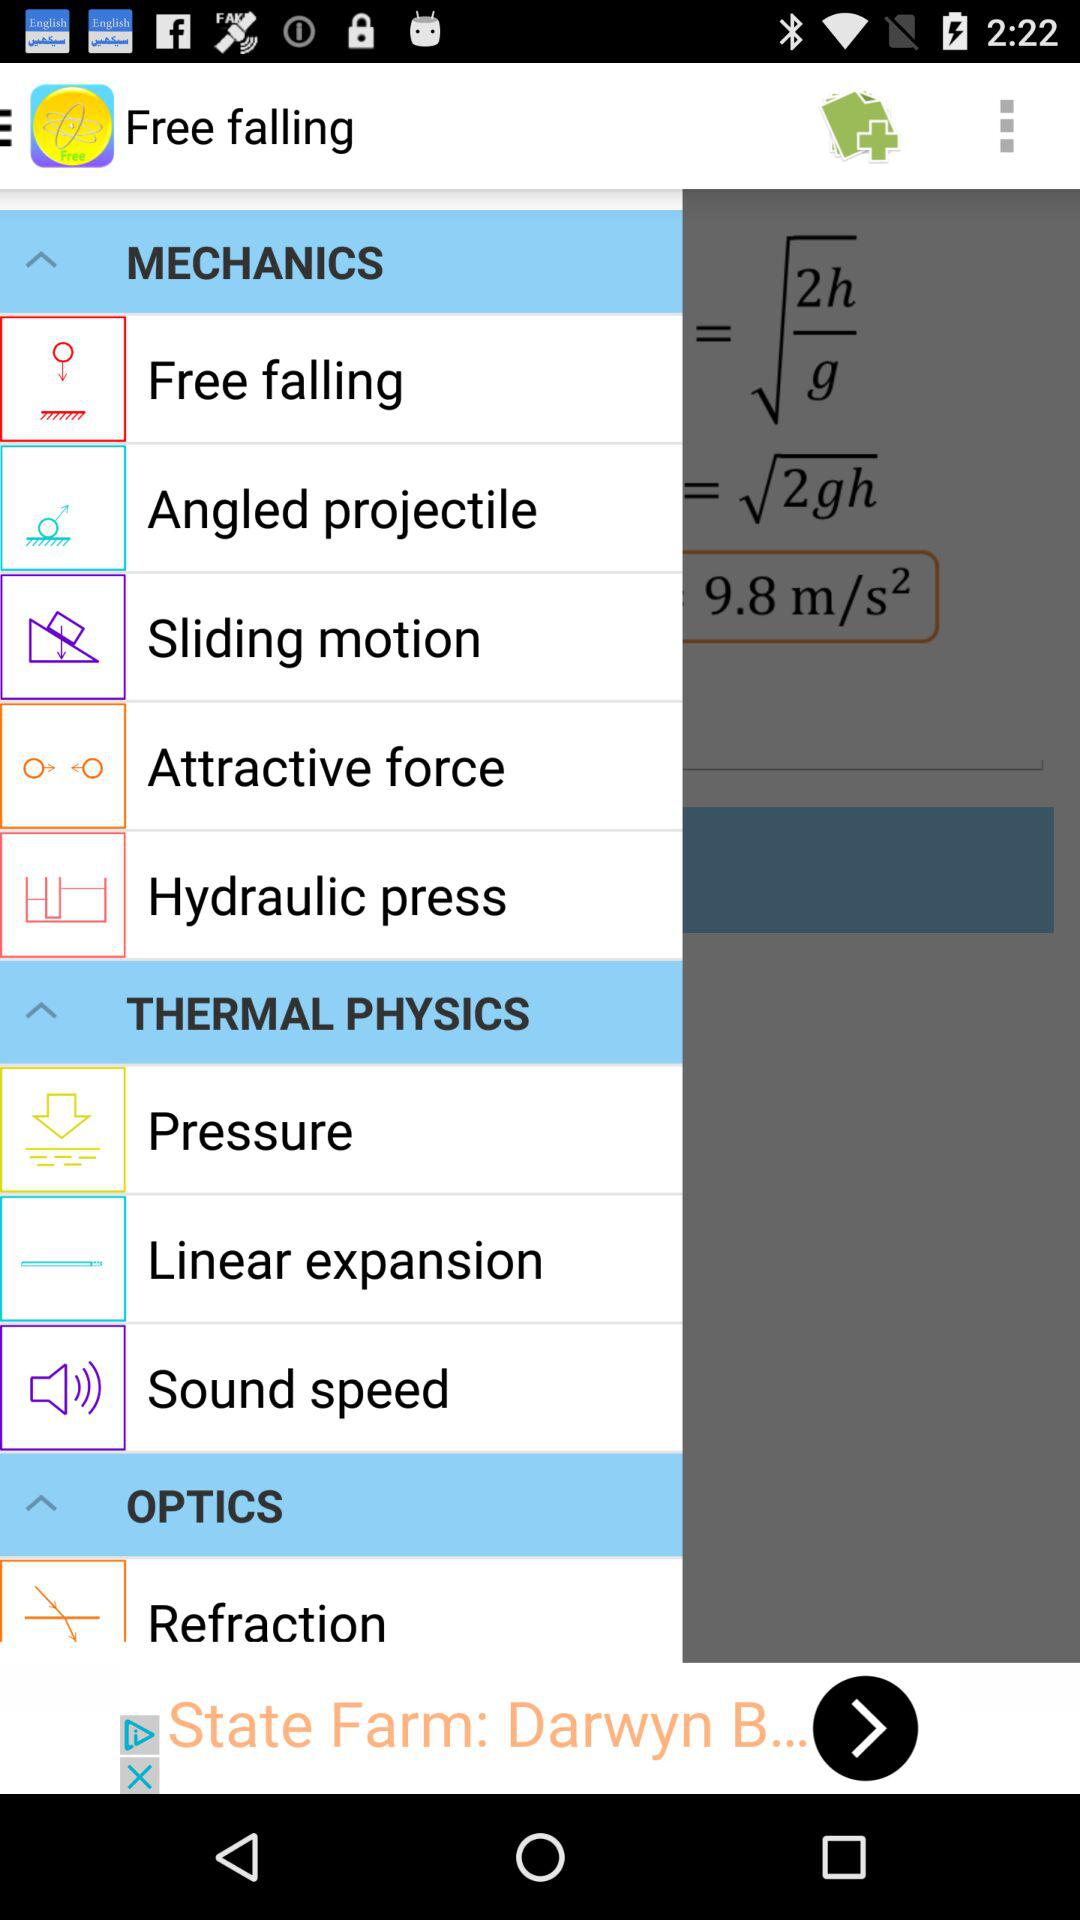What is the name of the application? The name of the application is "Free falling". 